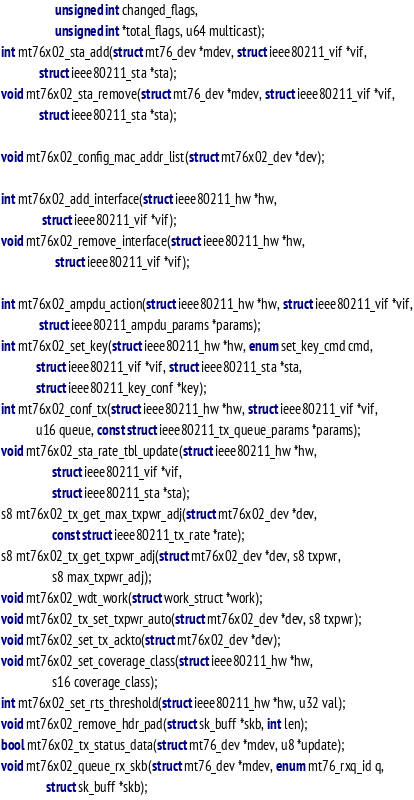Convert code to text. <code><loc_0><loc_0><loc_500><loc_500><_C_>			     unsigned int changed_flags,
			     unsigned int *total_flags, u64 multicast);
int mt76x02_sta_add(struct mt76_dev *mdev, struct ieee80211_vif *vif,
		    struct ieee80211_sta *sta);
void mt76x02_sta_remove(struct mt76_dev *mdev, struct ieee80211_vif *vif,
			struct ieee80211_sta *sta);

void mt76x02_config_mac_addr_list(struct mt76x02_dev *dev);

int mt76x02_add_interface(struct ieee80211_hw *hw,
			 struct ieee80211_vif *vif);
void mt76x02_remove_interface(struct ieee80211_hw *hw,
			     struct ieee80211_vif *vif);

int mt76x02_ampdu_action(struct ieee80211_hw *hw, struct ieee80211_vif *vif,
			struct ieee80211_ampdu_params *params);
int mt76x02_set_key(struct ieee80211_hw *hw, enum set_key_cmd cmd,
		   struct ieee80211_vif *vif, struct ieee80211_sta *sta,
		   struct ieee80211_key_conf *key);
int mt76x02_conf_tx(struct ieee80211_hw *hw, struct ieee80211_vif *vif,
		   u16 queue, const struct ieee80211_tx_queue_params *params);
void mt76x02_sta_rate_tbl_update(struct ieee80211_hw *hw,
				struct ieee80211_vif *vif,
				struct ieee80211_sta *sta);
s8 mt76x02_tx_get_max_txpwr_adj(struct mt76x02_dev *dev,
				const struct ieee80211_tx_rate *rate);
s8 mt76x02_tx_get_txpwr_adj(struct mt76x02_dev *dev, s8 txpwr,
			    s8 max_txpwr_adj);
void mt76x02_wdt_work(struct work_struct *work);
void mt76x02_tx_set_txpwr_auto(struct mt76x02_dev *dev, s8 txpwr);
void mt76x02_set_tx_ackto(struct mt76x02_dev *dev);
void mt76x02_set_coverage_class(struct ieee80211_hw *hw,
				s16 coverage_class);
int mt76x02_set_rts_threshold(struct ieee80211_hw *hw, u32 val);
void mt76x02_remove_hdr_pad(struct sk_buff *skb, int len);
bool mt76x02_tx_status_data(struct mt76_dev *mdev, u8 *update);
void mt76x02_queue_rx_skb(struct mt76_dev *mdev, enum mt76_rxq_id q,
			  struct sk_buff *skb);</code> 